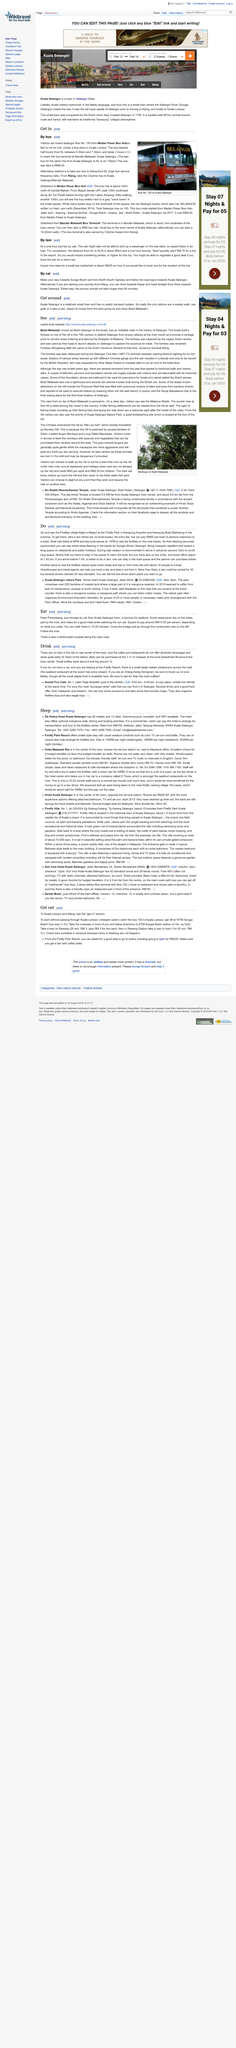Give some essential details in this illustration. Yes, there are buses from KL and Selangor that travel to Kuala Selangor, including Bus No. 100. The Selangor Bus No. 100 can be boarded at the Medan Pasar Bus Hub. It takes approximately two hours to reach the bus terminal at Bandar Malawati. 